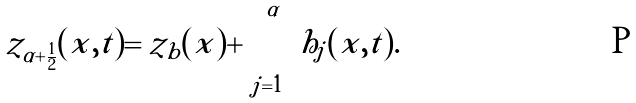Convert formula to latex. <formula><loc_0><loc_0><loc_500><loc_500>z _ { \alpha + \frac { 1 } { 2 } } ( x , t ) = z _ { b } ( x ) + \sum _ { j = 1 } ^ { \alpha } h _ { j } ( x , t ) .</formula> 